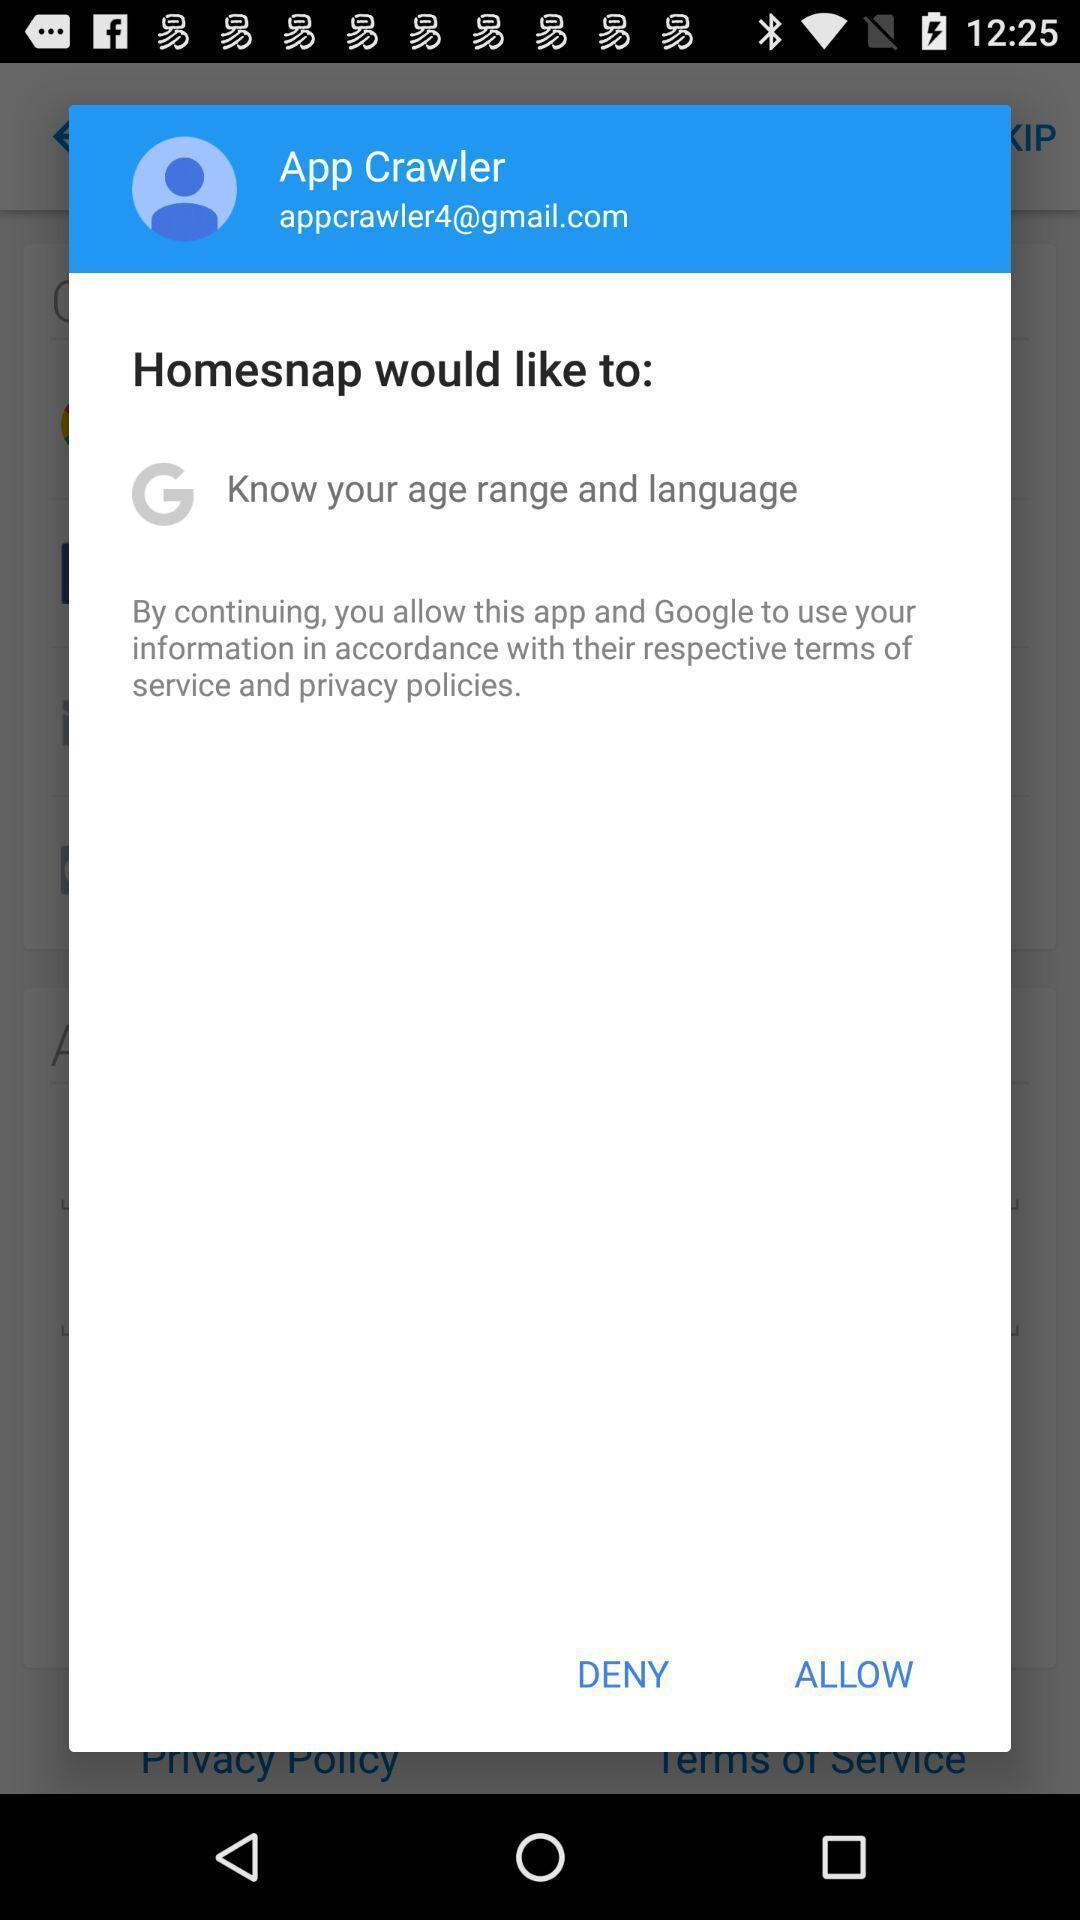Describe the content in this image. Pop-up displaying to allow the information to the app. 